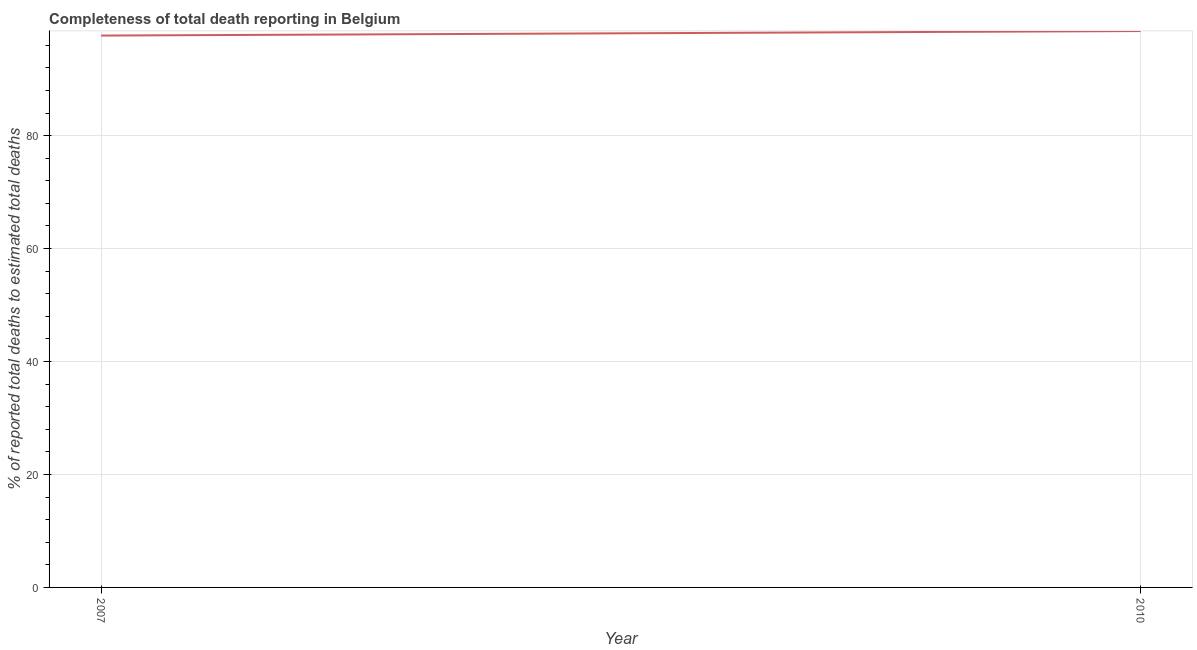What is the completeness of total death reports in 2007?
Your response must be concise. 97.72. Across all years, what is the maximum completeness of total death reports?
Provide a short and direct response. 98.52. Across all years, what is the minimum completeness of total death reports?
Your response must be concise. 97.72. What is the sum of the completeness of total death reports?
Keep it short and to the point. 196.24. What is the difference between the completeness of total death reports in 2007 and 2010?
Make the answer very short. -0.8. What is the average completeness of total death reports per year?
Provide a short and direct response. 98.12. What is the median completeness of total death reports?
Provide a short and direct response. 98.12. In how many years, is the completeness of total death reports greater than 60 %?
Your response must be concise. 2. What is the ratio of the completeness of total death reports in 2007 to that in 2010?
Provide a succinct answer. 0.99. Is the completeness of total death reports in 2007 less than that in 2010?
Offer a very short reply. Yes. In how many years, is the completeness of total death reports greater than the average completeness of total death reports taken over all years?
Give a very brief answer. 1. Does the completeness of total death reports monotonically increase over the years?
Provide a short and direct response. Yes. How many lines are there?
Your answer should be compact. 1. How many years are there in the graph?
Provide a short and direct response. 2. What is the difference between two consecutive major ticks on the Y-axis?
Your answer should be very brief. 20. What is the title of the graph?
Offer a terse response. Completeness of total death reporting in Belgium. What is the label or title of the Y-axis?
Provide a succinct answer. % of reported total deaths to estimated total deaths. What is the % of reported total deaths to estimated total deaths of 2007?
Offer a terse response. 97.72. What is the % of reported total deaths to estimated total deaths in 2010?
Your answer should be compact. 98.52. What is the difference between the % of reported total deaths to estimated total deaths in 2007 and 2010?
Offer a terse response. -0.8. 